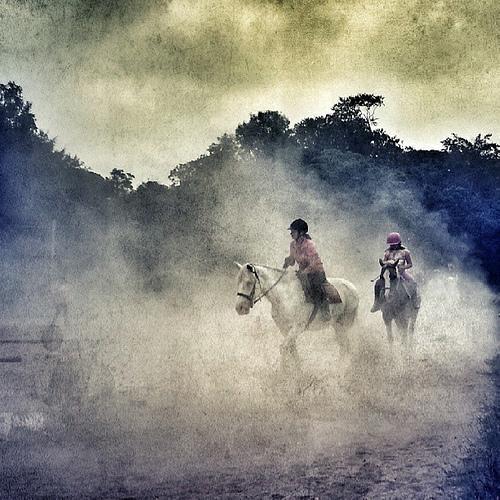How many people are there?
Give a very brief answer. 2. 